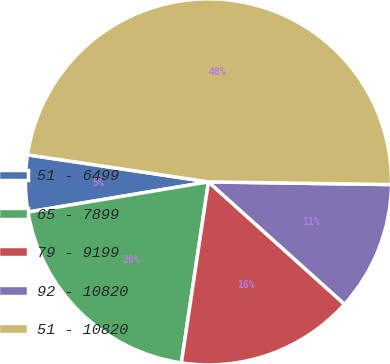Convert chart to OTSL. <chart><loc_0><loc_0><loc_500><loc_500><pie_chart><fcel>51 - 6499<fcel>65 - 7899<fcel>79 - 9199<fcel>92 - 10820<fcel>51 - 10820<nl><fcel>5.0%<fcel>20.0%<fcel>15.71%<fcel>11.42%<fcel>47.87%<nl></chart> 